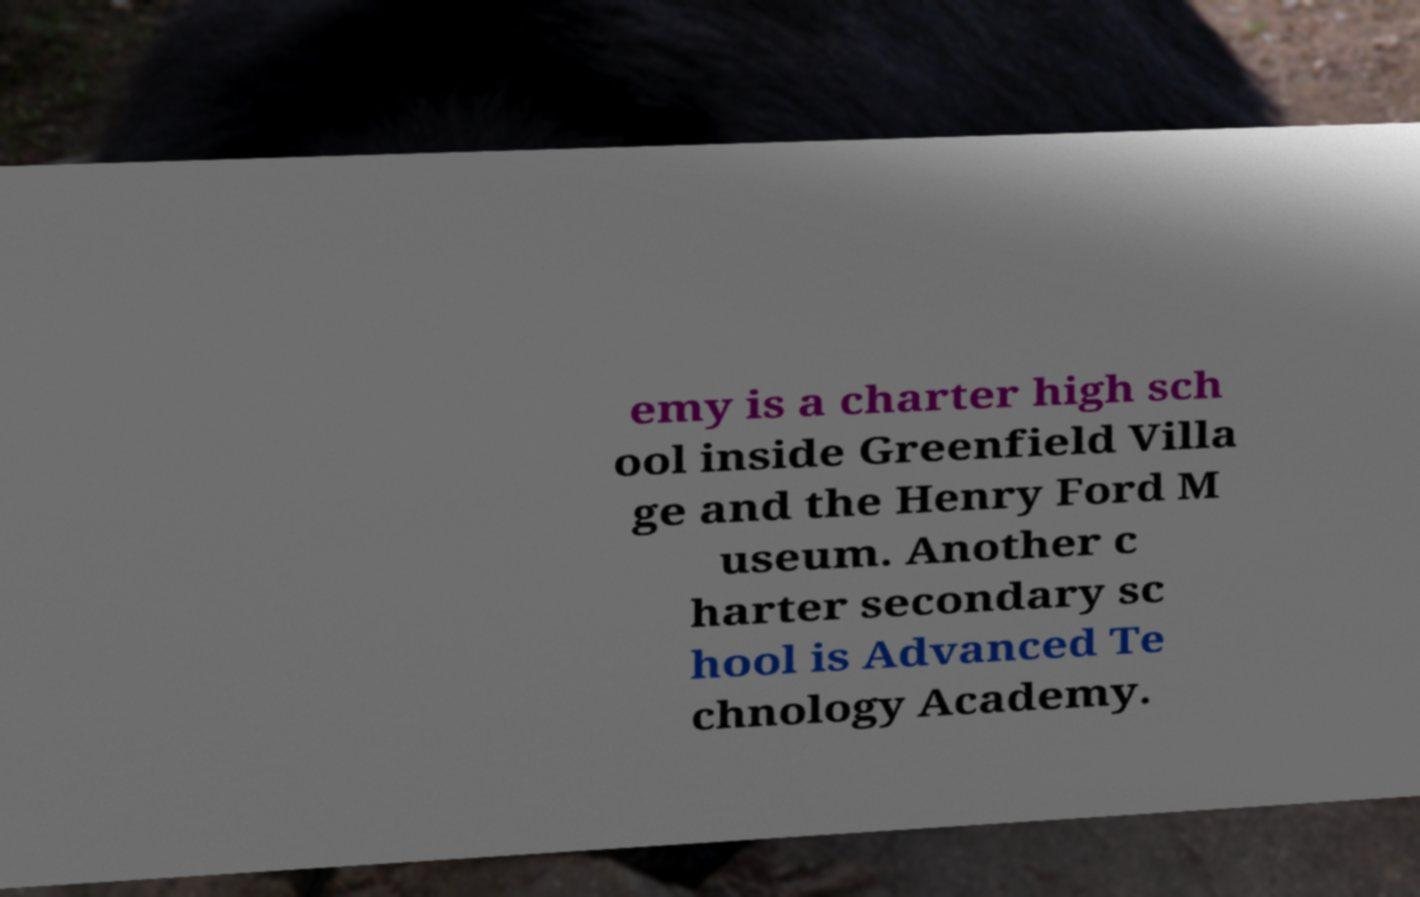Could you assist in decoding the text presented in this image and type it out clearly? emy is a charter high sch ool inside Greenfield Villa ge and the Henry Ford M useum. Another c harter secondary sc hool is Advanced Te chnology Academy. 